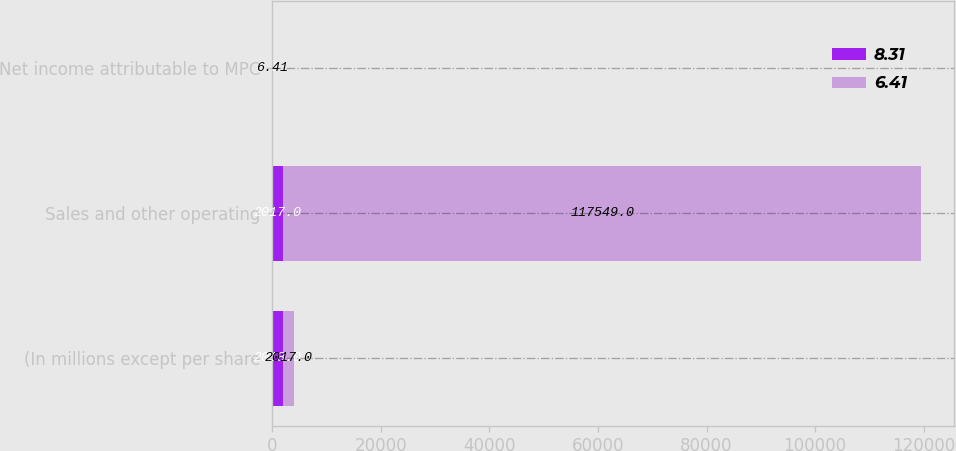<chart> <loc_0><loc_0><loc_500><loc_500><stacked_bar_chart><ecel><fcel>(In millions except per share<fcel>Sales and other operating<fcel>Net income attributable to MPC<nl><fcel>8.31<fcel>2018<fcel>2017<fcel>8.31<nl><fcel>6.41<fcel>2017<fcel>117549<fcel>6.41<nl></chart> 